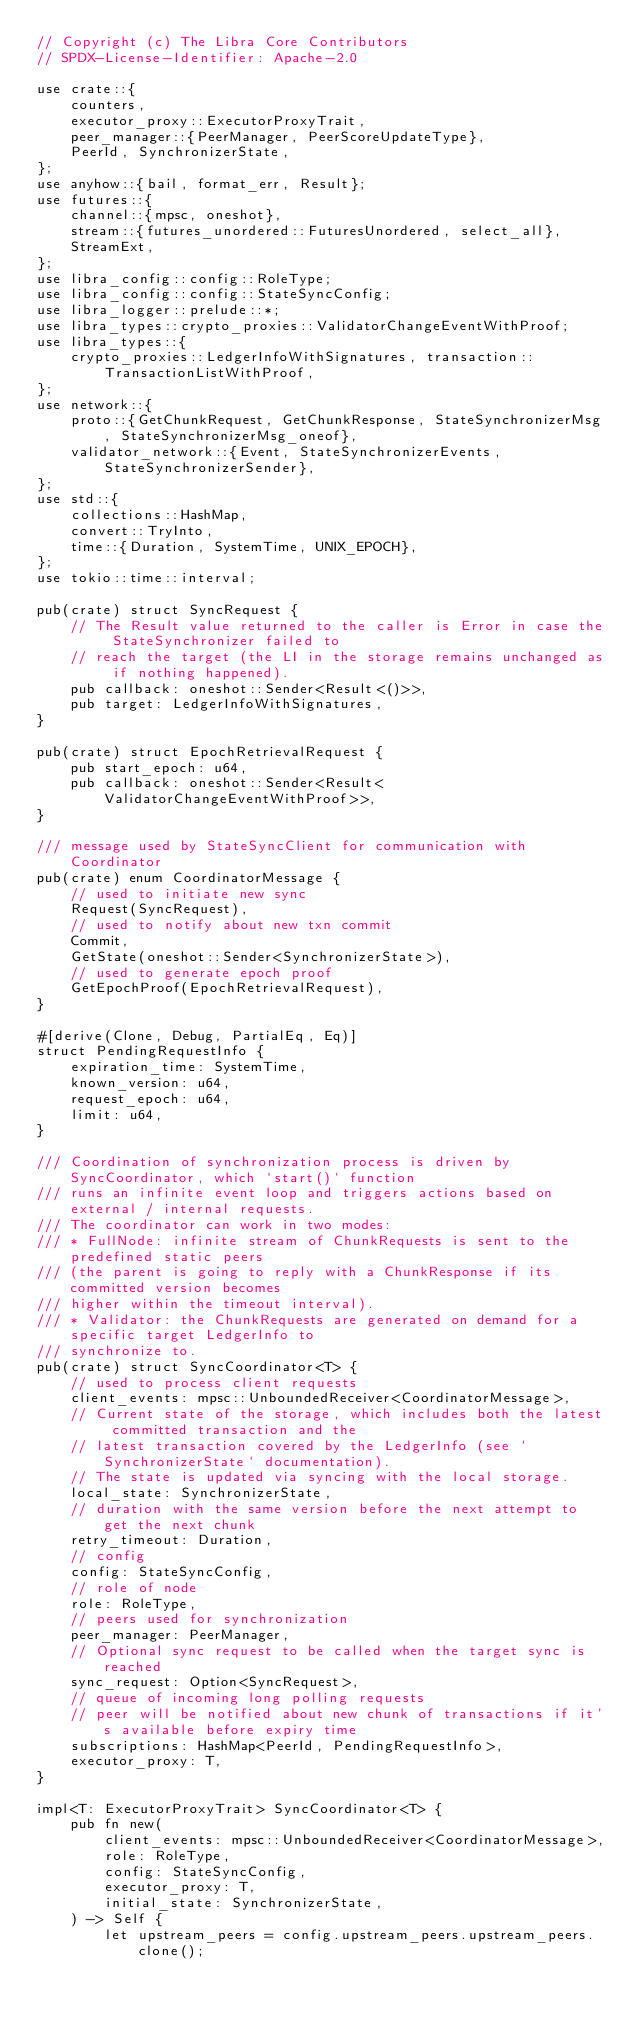Convert code to text. <code><loc_0><loc_0><loc_500><loc_500><_Rust_>// Copyright (c) The Libra Core Contributors
// SPDX-License-Identifier: Apache-2.0

use crate::{
    counters,
    executor_proxy::ExecutorProxyTrait,
    peer_manager::{PeerManager, PeerScoreUpdateType},
    PeerId, SynchronizerState,
};
use anyhow::{bail, format_err, Result};
use futures::{
    channel::{mpsc, oneshot},
    stream::{futures_unordered::FuturesUnordered, select_all},
    StreamExt,
};
use libra_config::config::RoleType;
use libra_config::config::StateSyncConfig;
use libra_logger::prelude::*;
use libra_types::crypto_proxies::ValidatorChangeEventWithProof;
use libra_types::{
    crypto_proxies::LedgerInfoWithSignatures, transaction::TransactionListWithProof,
};
use network::{
    proto::{GetChunkRequest, GetChunkResponse, StateSynchronizerMsg, StateSynchronizerMsg_oneof},
    validator_network::{Event, StateSynchronizerEvents, StateSynchronizerSender},
};
use std::{
    collections::HashMap,
    convert::TryInto,
    time::{Duration, SystemTime, UNIX_EPOCH},
};
use tokio::time::interval;

pub(crate) struct SyncRequest {
    // The Result value returned to the caller is Error in case the StateSynchronizer failed to
    // reach the target (the LI in the storage remains unchanged as if nothing happened).
    pub callback: oneshot::Sender<Result<()>>,
    pub target: LedgerInfoWithSignatures,
}

pub(crate) struct EpochRetrievalRequest {
    pub start_epoch: u64,
    pub callback: oneshot::Sender<Result<ValidatorChangeEventWithProof>>,
}

/// message used by StateSyncClient for communication with Coordinator
pub(crate) enum CoordinatorMessage {
    // used to initiate new sync
    Request(SyncRequest),
    // used to notify about new txn commit
    Commit,
    GetState(oneshot::Sender<SynchronizerState>),
    // used to generate epoch proof
    GetEpochProof(EpochRetrievalRequest),
}

#[derive(Clone, Debug, PartialEq, Eq)]
struct PendingRequestInfo {
    expiration_time: SystemTime,
    known_version: u64,
    request_epoch: u64,
    limit: u64,
}

/// Coordination of synchronization process is driven by SyncCoordinator, which `start()` function
/// runs an infinite event loop and triggers actions based on external / internal requests.
/// The coordinator can work in two modes:
/// * FullNode: infinite stream of ChunkRequests is sent to the predefined static peers
/// (the parent is going to reply with a ChunkResponse if its committed version becomes
/// higher within the timeout interval).
/// * Validator: the ChunkRequests are generated on demand for a specific target LedgerInfo to
/// synchronize to.
pub(crate) struct SyncCoordinator<T> {
    // used to process client requests
    client_events: mpsc::UnboundedReceiver<CoordinatorMessage>,
    // Current state of the storage, which includes both the latest committed transaction and the
    // latest transaction covered by the LedgerInfo (see `SynchronizerState` documentation).
    // The state is updated via syncing with the local storage.
    local_state: SynchronizerState,
    // duration with the same version before the next attempt to get the next chunk
    retry_timeout: Duration,
    // config
    config: StateSyncConfig,
    // role of node
    role: RoleType,
    // peers used for synchronization
    peer_manager: PeerManager,
    // Optional sync request to be called when the target sync is reached
    sync_request: Option<SyncRequest>,
    // queue of incoming long polling requests
    // peer will be notified about new chunk of transactions if it's available before expiry time
    subscriptions: HashMap<PeerId, PendingRequestInfo>,
    executor_proxy: T,
}

impl<T: ExecutorProxyTrait> SyncCoordinator<T> {
    pub fn new(
        client_events: mpsc::UnboundedReceiver<CoordinatorMessage>,
        role: RoleType,
        config: StateSyncConfig,
        executor_proxy: T,
        initial_state: SynchronizerState,
    ) -> Self {
        let upstream_peers = config.upstream_peers.upstream_peers.clone();</code> 